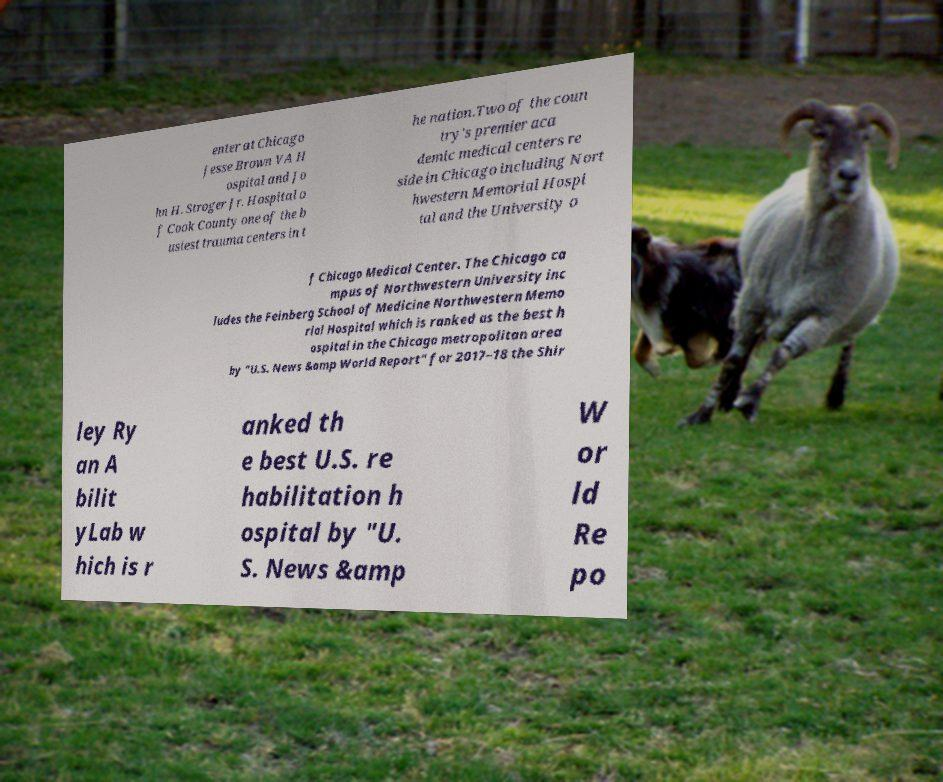What messages or text are displayed in this image? I need them in a readable, typed format. enter at Chicago Jesse Brown VA H ospital and Jo hn H. Stroger Jr. Hospital o f Cook County one of the b usiest trauma centers in t he nation.Two of the coun try's premier aca demic medical centers re side in Chicago including Nort hwestern Memorial Hospi tal and the University o f Chicago Medical Center. The Chicago ca mpus of Northwestern University inc ludes the Feinberg School of Medicine Northwestern Memo rial Hospital which is ranked as the best h ospital in the Chicago metropolitan area by "U.S. News &amp World Report" for 2017–18 the Shir ley Ry an A bilit yLab w hich is r anked th e best U.S. re habilitation h ospital by "U. S. News &amp W or ld Re po 